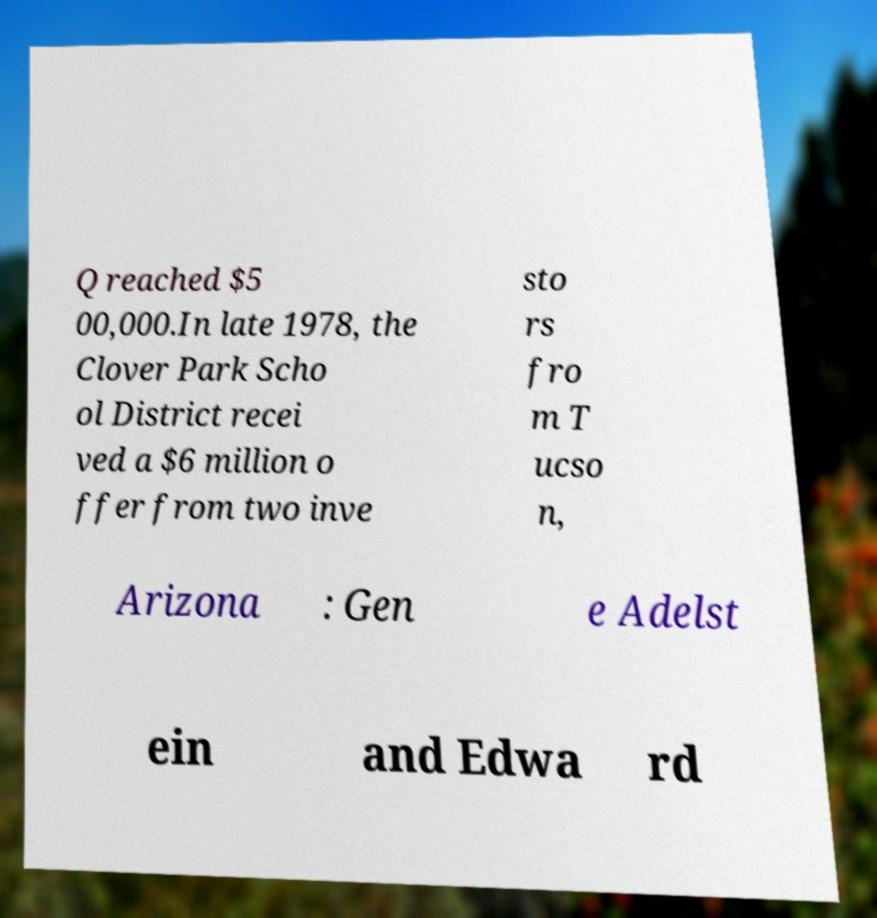What messages or text are displayed in this image? I need them in a readable, typed format. Q reached $5 00,000.In late 1978, the Clover Park Scho ol District recei ved a $6 million o ffer from two inve sto rs fro m T ucso n, Arizona : Gen e Adelst ein and Edwa rd 